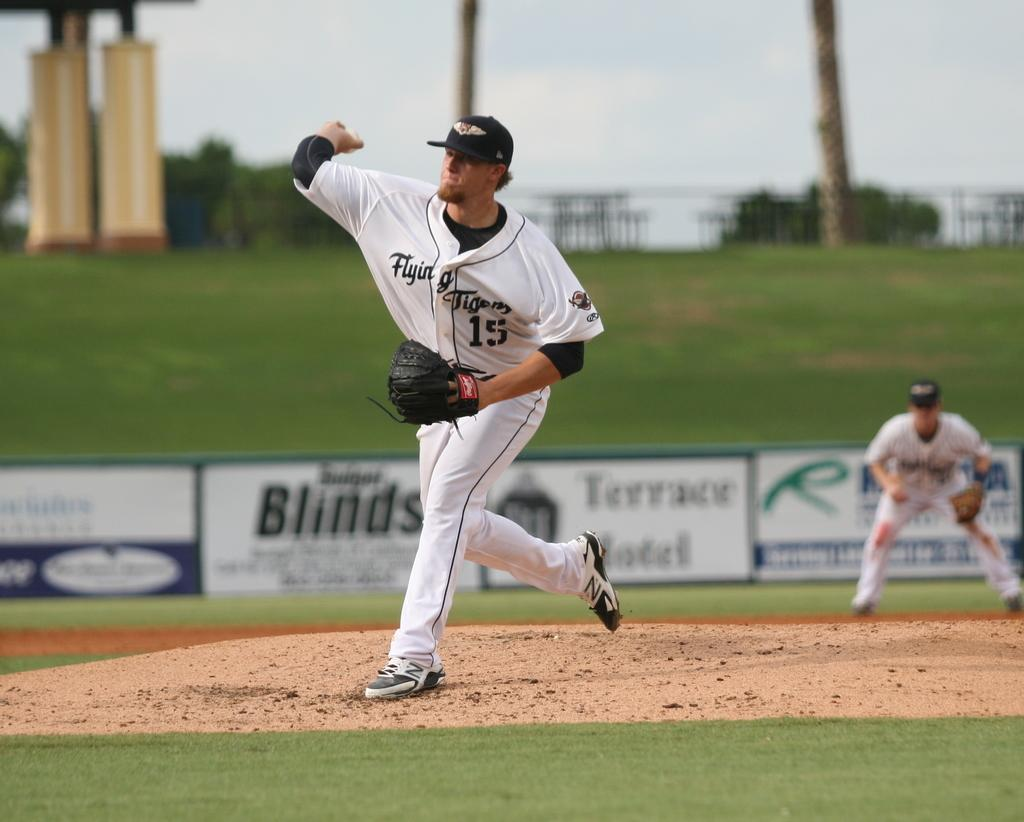<image>
Provide a brief description of the given image. The pitcher, who is number 15, is about to pitch the baseball. 